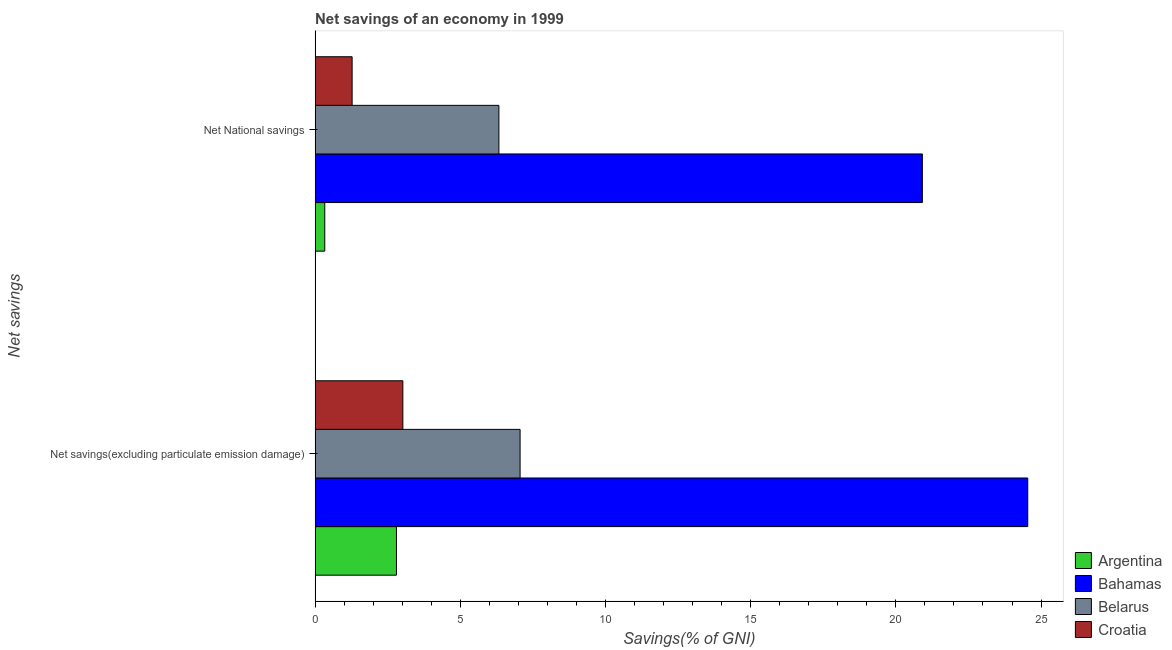How many different coloured bars are there?
Make the answer very short. 4. How many bars are there on the 2nd tick from the top?
Keep it short and to the point. 4. How many bars are there on the 1st tick from the bottom?
Offer a very short reply. 4. What is the label of the 2nd group of bars from the top?
Make the answer very short. Net savings(excluding particulate emission damage). What is the net national savings in Croatia?
Give a very brief answer. 1.28. Across all countries, what is the maximum net savings(excluding particulate emission damage)?
Offer a terse response. 24.54. Across all countries, what is the minimum net national savings?
Your answer should be compact. 0.33. In which country was the net national savings maximum?
Give a very brief answer. Bahamas. What is the total net national savings in the graph?
Your response must be concise. 28.85. What is the difference between the net savings(excluding particulate emission damage) in Belarus and that in Argentina?
Offer a very short reply. 4.26. What is the difference between the net savings(excluding particulate emission damage) in Argentina and the net national savings in Belarus?
Your response must be concise. -3.53. What is the average net national savings per country?
Make the answer very short. 7.21. What is the difference between the net national savings and net savings(excluding particulate emission damage) in Belarus?
Keep it short and to the point. -0.73. What is the ratio of the net savings(excluding particulate emission damage) in Belarus to that in Croatia?
Offer a very short reply. 2.34. Is the net savings(excluding particulate emission damage) in Argentina less than that in Belarus?
Offer a terse response. Yes. In how many countries, is the net national savings greater than the average net national savings taken over all countries?
Your answer should be very brief. 1. What does the 2nd bar from the bottom in Net savings(excluding particulate emission damage) represents?
Offer a very short reply. Bahamas. Are all the bars in the graph horizontal?
Your answer should be very brief. Yes. What is the difference between two consecutive major ticks on the X-axis?
Give a very brief answer. 5. Does the graph contain grids?
Provide a succinct answer. No. How many legend labels are there?
Provide a succinct answer. 4. What is the title of the graph?
Your answer should be very brief. Net savings of an economy in 1999. What is the label or title of the X-axis?
Make the answer very short. Savings(% of GNI). What is the label or title of the Y-axis?
Give a very brief answer. Net savings. What is the Savings(% of GNI) in Argentina in Net savings(excluding particulate emission damage)?
Provide a succinct answer. 2.8. What is the Savings(% of GNI) of Bahamas in Net savings(excluding particulate emission damage)?
Make the answer very short. 24.54. What is the Savings(% of GNI) of Belarus in Net savings(excluding particulate emission damage)?
Provide a succinct answer. 7.06. What is the Savings(% of GNI) of Croatia in Net savings(excluding particulate emission damage)?
Your response must be concise. 3.02. What is the Savings(% of GNI) of Argentina in Net National savings?
Provide a short and direct response. 0.33. What is the Savings(% of GNI) of Bahamas in Net National savings?
Ensure brevity in your answer.  20.91. What is the Savings(% of GNI) of Belarus in Net National savings?
Provide a succinct answer. 6.33. What is the Savings(% of GNI) of Croatia in Net National savings?
Ensure brevity in your answer.  1.28. Across all Net savings, what is the maximum Savings(% of GNI) of Argentina?
Provide a short and direct response. 2.8. Across all Net savings, what is the maximum Savings(% of GNI) in Bahamas?
Make the answer very short. 24.54. Across all Net savings, what is the maximum Savings(% of GNI) of Belarus?
Your answer should be very brief. 7.06. Across all Net savings, what is the maximum Savings(% of GNI) of Croatia?
Offer a terse response. 3.02. Across all Net savings, what is the minimum Savings(% of GNI) of Argentina?
Your answer should be compact. 0.33. Across all Net savings, what is the minimum Savings(% of GNI) in Bahamas?
Make the answer very short. 20.91. Across all Net savings, what is the minimum Savings(% of GNI) of Belarus?
Provide a succinct answer. 6.33. Across all Net savings, what is the minimum Savings(% of GNI) of Croatia?
Offer a very short reply. 1.28. What is the total Savings(% of GNI) of Argentina in the graph?
Your answer should be very brief. 3.13. What is the total Savings(% of GNI) of Bahamas in the graph?
Offer a very short reply. 45.45. What is the total Savings(% of GNI) in Belarus in the graph?
Make the answer very short. 13.39. What is the total Savings(% of GNI) of Croatia in the graph?
Make the answer very short. 4.3. What is the difference between the Savings(% of GNI) in Argentina in Net savings(excluding particulate emission damage) and that in Net National savings?
Your response must be concise. 2.47. What is the difference between the Savings(% of GNI) in Bahamas in Net savings(excluding particulate emission damage) and that in Net National savings?
Give a very brief answer. 3.63. What is the difference between the Savings(% of GNI) in Belarus in Net savings(excluding particulate emission damage) and that in Net National savings?
Your answer should be compact. 0.73. What is the difference between the Savings(% of GNI) of Croatia in Net savings(excluding particulate emission damage) and that in Net National savings?
Your answer should be very brief. 1.75. What is the difference between the Savings(% of GNI) of Argentina in Net savings(excluding particulate emission damage) and the Savings(% of GNI) of Bahamas in Net National savings?
Offer a very short reply. -18.11. What is the difference between the Savings(% of GNI) of Argentina in Net savings(excluding particulate emission damage) and the Savings(% of GNI) of Belarus in Net National savings?
Your response must be concise. -3.53. What is the difference between the Savings(% of GNI) of Argentina in Net savings(excluding particulate emission damage) and the Savings(% of GNI) of Croatia in Net National savings?
Your response must be concise. 1.53. What is the difference between the Savings(% of GNI) of Bahamas in Net savings(excluding particulate emission damage) and the Savings(% of GNI) of Belarus in Net National savings?
Your answer should be compact. 18.21. What is the difference between the Savings(% of GNI) in Bahamas in Net savings(excluding particulate emission damage) and the Savings(% of GNI) in Croatia in Net National savings?
Provide a short and direct response. 23.27. What is the difference between the Savings(% of GNI) of Belarus in Net savings(excluding particulate emission damage) and the Savings(% of GNI) of Croatia in Net National savings?
Provide a short and direct response. 5.78. What is the average Savings(% of GNI) of Argentina per Net savings?
Provide a short and direct response. 1.57. What is the average Savings(% of GNI) of Bahamas per Net savings?
Offer a very short reply. 22.73. What is the average Savings(% of GNI) of Belarus per Net savings?
Provide a short and direct response. 6.69. What is the average Savings(% of GNI) in Croatia per Net savings?
Your answer should be compact. 2.15. What is the difference between the Savings(% of GNI) in Argentina and Savings(% of GNI) in Bahamas in Net savings(excluding particulate emission damage)?
Your response must be concise. -21.74. What is the difference between the Savings(% of GNI) of Argentina and Savings(% of GNI) of Belarus in Net savings(excluding particulate emission damage)?
Provide a short and direct response. -4.26. What is the difference between the Savings(% of GNI) in Argentina and Savings(% of GNI) in Croatia in Net savings(excluding particulate emission damage)?
Provide a succinct answer. -0.22. What is the difference between the Savings(% of GNI) in Bahamas and Savings(% of GNI) in Belarus in Net savings(excluding particulate emission damage)?
Give a very brief answer. 17.48. What is the difference between the Savings(% of GNI) of Bahamas and Savings(% of GNI) of Croatia in Net savings(excluding particulate emission damage)?
Give a very brief answer. 21.52. What is the difference between the Savings(% of GNI) in Belarus and Savings(% of GNI) in Croatia in Net savings(excluding particulate emission damage)?
Make the answer very short. 4.04. What is the difference between the Savings(% of GNI) in Argentina and Savings(% of GNI) in Bahamas in Net National savings?
Give a very brief answer. -20.58. What is the difference between the Savings(% of GNI) of Argentina and Savings(% of GNI) of Belarus in Net National savings?
Provide a succinct answer. -6. What is the difference between the Savings(% of GNI) in Argentina and Savings(% of GNI) in Croatia in Net National savings?
Your answer should be very brief. -0.94. What is the difference between the Savings(% of GNI) of Bahamas and Savings(% of GNI) of Belarus in Net National savings?
Offer a very short reply. 14.58. What is the difference between the Savings(% of GNI) in Bahamas and Savings(% of GNI) in Croatia in Net National savings?
Provide a succinct answer. 19.64. What is the difference between the Savings(% of GNI) in Belarus and Savings(% of GNI) in Croatia in Net National savings?
Your answer should be very brief. 5.05. What is the ratio of the Savings(% of GNI) in Argentina in Net savings(excluding particulate emission damage) to that in Net National savings?
Keep it short and to the point. 8.42. What is the ratio of the Savings(% of GNI) in Bahamas in Net savings(excluding particulate emission damage) to that in Net National savings?
Your answer should be very brief. 1.17. What is the ratio of the Savings(% of GNI) of Belarus in Net savings(excluding particulate emission damage) to that in Net National savings?
Keep it short and to the point. 1.12. What is the ratio of the Savings(% of GNI) of Croatia in Net savings(excluding particulate emission damage) to that in Net National savings?
Provide a succinct answer. 2.37. What is the difference between the highest and the second highest Savings(% of GNI) in Argentina?
Provide a short and direct response. 2.47. What is the difference between the highest and the second highest Savings(% of GNI) of Bahamas?
Provide a succinct answer. 3.63. What is the difference between the highest and the second highest Savings(% of GNI) of Belarus?
Ensure brevity in your answer.  0.73. What is the difference between the highest and the second highest Savings(% of GNI) of Croatia?
Offer a terse response. 1.75. What is the difference between the highest and the lowest Savings(% of GNI) in Argentina?
Offer a very short reply. 2.47. What is the difference between the highest and the lowest Savings(% of GNI) of Bahamas?
Ensure brevity in your answer.  3.63. What is the difference between the highest and the lowest Savings(% of GNI) of Belarus?
Your response must be concise. 0.73. What is the difference between the highest and the lowest Savings(% of GNI) of Croatia?
Make the answer very short. 1.75. 